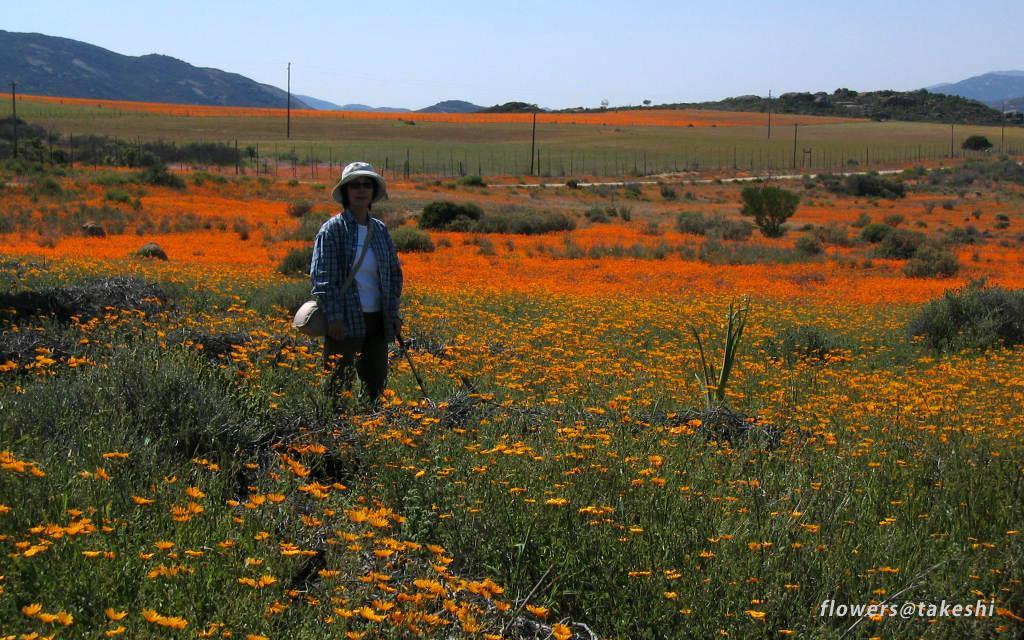In one or two sentences, can you explain what this image depicts? In this image we can see there is the person standing and holding the stick. And there are plants with flowers. And there are poles, mountains and the sky. 